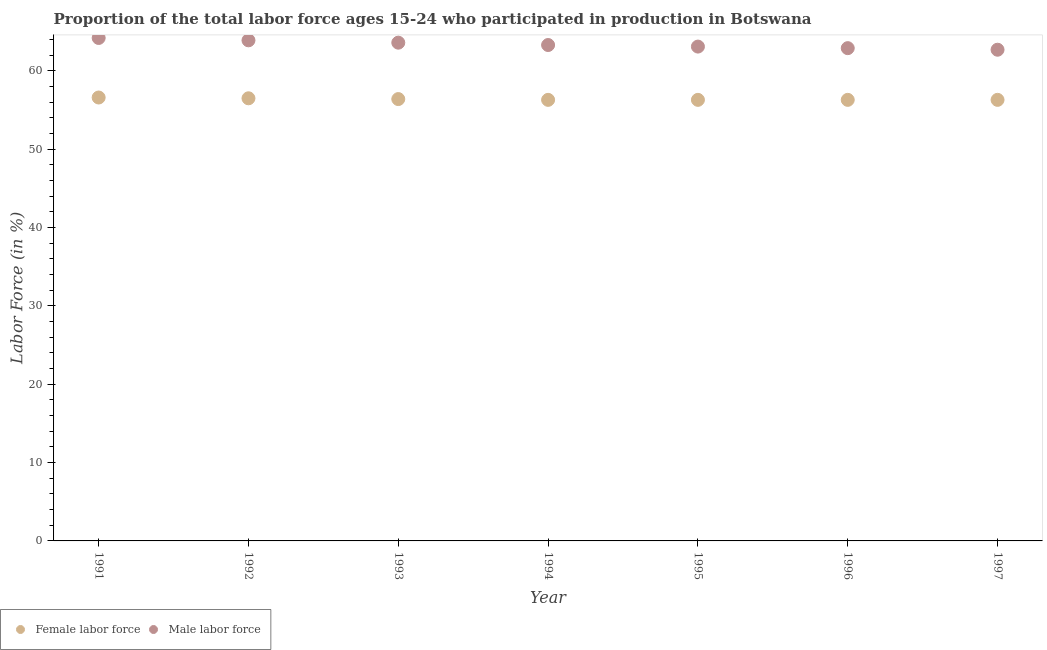How many different coloured dotlines are there?
Ensure brevity in your answer.  2. Is the number of dotlines equal to the number of legend labels?
Make the answer very short. Yes. What is the percentage of male labour force in 1995?
Give a very brief answer. 63.1. Across all years, what is the maximum percentage of female labor force?
Provide a succinct answer. 56.6. Across all years, what is the minimum percentage of male labour force?
Your answer should be very brief. 62.7. In which year was the percentage of male labour force minimum?
Ensure brevity in your answer.  1997. What is the total percentage of male labour force in the graph?
Your answer should be very brief. 443.7. What is the difference between the percentage of female labor force in 1991 and that in 1995?
Your answer should be compact. 0.3. What is the difference between the percentage of female labor force in 1993 and the percentage of male labour force in 1995?
Your response must be concise. -6.7. What is the average percentage of female labor force per year?
Make the answer very short. 56.39. In the year 1992, what is the difference between the percentage of male labour force and percentage of female labor force?
Ensure brevity in your answer.  7.4. What is the ratio of the percentage of male labour force in 1993 to that in 1996?
Your response must be concise. 1.01. Is the percentage of male labour force in 1994 less than that in 1995?
Make the answer very short. No. Is the difference between the percentage of male labour force in 1994 and 1995 greater than the difference between the percentage of female labor force in 1994 and 1995?
Make the answer very short. Yes. What is the difference between the highest and the second highest percentage of female labor force?
Your answer should be very brief. 0.1. What is the difference between the highest and the lowest percentage of female labor force?
Your response must be concise. 0.3. How many dotlines are there?
Ensure brevity in your answer.  2. How many years are there in the graph?
Provide a succinct answer. 7. Are the values on the major ticks of Y-axis written in scientific E-notation?
Provide a short and direct response. No. Does the graph contain grids?
Your response must be concise. No. What is the title of the graph?
Provide a short and direct response. Proportion of the total labor force ages 15-24 who participated in production in Botswana. What is the label or title of the X-axis?
Make the answer very short. Year. What is the label or title of the Y-axis?
Give a very brief answer. Labor Force (in %). What is the Labor Force (in %) of Female labor force in 1991?
Offer a very short reply. 56.6. What is the Labor Force (in %) in Male labor force in 1991?
Give a very brief answer. 64.2. What is the Labor Force (in %) of Female labor force in 1992?
Keep it short and to the point. 56.5. What is the Labor Force (in %) in Male labor force in 1992?
Your answer should be very brief. 63.9. What is the Labor Force (in %) in Female labor force in 1993?
Offer a very short reply. 56.4. What is the Labor Force (in %) in Male labor force in 1993?
Provide a succinct answer. 63.6. What is the Labor Force (in %) of Female labor force in 1994?
Your answer should be very brief. 56.3. What is the Labor Force (in %) of Male labor force in 1994?
Offer a very short reply. 63.3. What is the Labor Force (in %) of Female labor force in 1995?
Make the answer very short. 56.3. What is the Labor Force (in %) in Male labor force in 1995?
Provide a succinct answer. 63.1. What is the Labor Force (in %) in Female labor force in 1996?
Provide a succinct answer. 56.3. What is the Labor Force (in %) of Male labor force in 1996?
Keep it short and to the point. 62.9. What is the Labor Force (in %) of Female labor force in 1997?
Your answer should be very brief. 56.3. What is the Labor Force (in %) in Male labor force in 1997?
Offer a very short reply. 62.7. Across all years, what is the maximum Labor Force (in %) in Female labor force?
Offer a very short reply. 56.6. Across all years, what is the maximum Labor Force (in %) of Male labor force?
Your response must be concise. 64.2. Across all years, what is the minimum Labor Force (in %) in Female labor force?
Keep it short and to the point. 56.3. Across all years, what is the minimum Labor Force (in %) in Male labor force?
Provide a short and direct response. 62.7. What is the total Labor Force (in %) in Female labor force in the graph?
Your answer should be compact. 394.7. What is the total Labor Force (in %) in Male labor force in the graph?
Keep it short and to the point. 443.7. What is the difference between the Labor Force (in %) of Male labor force in 1991 and that in 1992?
Provide a short and direct response. 0.3. What is the difference between the Labor Force (in %) in Male labor force in 1991 and that in 1994?
Provide a short and direct response. 0.9. What is the difference between the Labor Force (in %) of Female labor force in 1991 and that in 1995?
Offer a terse response. 0.3. What is the difference between the Labor Force (in %) in Female labor force in 1991 and that in 1996?
Offer a terse response. 0.3. What is the difference between the Labor Force (in %) in Female labor force in 1991 and that in 1997?
Make the answer very short. 0.3. What is the difference between the Labor Force (in %) of Female labor force in 1992 and that in 1993?
Offer a very short reply. 0.1. What is the difference between the Labor Force (in %) of Male labor force in 1992 and that in 1994?
Provide a short and direct response. 0.6. What is the difference between the Labor Force (in %) of Female labor force in 1992 and that in 1995?
Your answer should be compact. 0.2. What is the difference between the Labor Force (in %) of Male labor force in 1992 and that in 1996?
Provide a short and direct response. 1. What is the difference between the Labor Force (in %) of Male labor force in 1992 and that in 1997?
Your answer should be very brief. 1.2. What is the difference between the Labor Force (in %) in Female labor force in 1993 and that in 1995?
Your response must be concise. 0.1. What is the difference between the Labor Force (in %) in Male labor force in 1993 and that in 1995?
Your answer should be very brief. 0.5. What is the difference between the Labor Force (in %) of Female labor force in 1994 and that in 1995?
Offer a very short reply. 0. What is the difference between the Labor Force (in %) of Male labor force in 1994 and that in 1995?
Offer a terse response. 0.2. What is the difference between the Labor Force (in %) in Female labor force in 1994 and that in 1996?
Offer a terse response. 0. What is the difference between the Labor Force (in %) of Male labor force in 1994 and that in 1996?
Your answer should be compact. 0.4. What is the difference between the Labor Force (in %) of Male labor force in 1994 and that in 1997?
Make the answer very short. 0.6. What is the difference between the Labor Force (in %) of Female labor force in 1995 and that in 1996?
Ensure brevity in your answer.  0. What is the difference between the Labor Force (in %) in Male labor force in 1995 and that in 1996?
Your answer should be compact. 0.2. What is the difference between the Labor Force (in %) in Male labor force in 1996 and that in 1997?
Provide a short and direct response. 0.2. What is the difference between the Labor Force (in %) in Female labor force in 1991 and the Labor Force (in %) in Male labor force in 1992?
Ensure brevity in your answer.  -7.3. What is the difference between the Labor Force (in %) in Female labor force in 1991 and the Labor Force (in %) in Male labor force in 1993?
Give a very brief answer. -7. What is the difference between the Labor Force (in %) of Female labor force in 1991 and the Labor Force (in %) of Male labor force in 1994?
Provide a succinct answer. -6.7. What is the difference between the Labor Force (in %) in Female labor force in 1991 and the Labor Force (in %) in Male labor force in 1997?
Provide a succinct answer. -6.1. What is the difference between the Labor Force (in %) in Female labor force in 1992 and the Labor Force (in %) in Male labor force in 1993?
Provide a succinct answer. -7.1. What is the difference between the Labor Force (in %) in Female labor force in 1992 and the Labor Force (in %) in Male labor force in 1996?
Provide a succinct answer. -6.4. What is the difference between the Labor Force (in %) in Female labor force in 1992 and the Labor Force (in %) in Male labor force in 1997?
Offer a terse response. -6.2. What is the difference between the Labor Force (in %) of Female labor force in 1994 and the Labor Force (in %) of Male labor force in 1995?
Offer a very short reply. -6.8. What is the difference between the Labor Force (in %) of Female labor force in 1994 and the Labor Force (in %) of Male labor force in 1996?
Your answer should be compact. -6.6. What is the difference between the Labor Force (in %) in Female labor force in 1996 and the Labor Force (in %) in Male labor force in 1997?
Provide a short and direct response. -6.4. What is the average Labor Force (in %) of Female labor force per year?
Ensure brevity in your answer.  56.39. What is the average Labor Force (in %) in Male labor force per year?
Your answer should be compact. 63.39. In the year 1994, what is the difference between the Labor Force (in %) in Female labor force and Labor Force (in %) in Male labor force?
Provide a succinct answer. -7. What is the ratio of the Labor Force (in %) of Female labor force in 1991 to that in 1993?
Your answer should be very brief. 1. What is the ratio of the Labor Force (in %) of Male labor force in 1991 to that in 1993?
Ensure brevity in your answer.  1.01. What is the ratio of the Labor Force (in %) in Male labor force in 1991 to that in 1994?
Make the answer very short. 1.01. What is the ratio of the Labor Force (in %) of Male labor force in 1991 to that in 1995?
Your answer should be compact. 1.02. What is the ratio of the Labor Force (in %) in Male labor force in 1991 to that in 1996?
Offer a very short reply. 1.02. What is the ratio of the Labor Force (in %) in Female labor force in 1991 to that in 1997?
Keep it short and to the point. 1.01. What is the ratio of the Labor Force (in %) in Male labor force in 1991 to that in 1997?
Provide a succinct answer. 1.02. What is the ratio of the Labor Force (in %) of Female labor force in 1992 to that in 1993?
Give a very brief answer. 1. What is the ratio of the Labor Force (in %) in Female labor force in 1992 to that in 1994?
Ensure brevity in your answer.  1. What is the ratio of the Labor Force (in %) in Male labor force in 1992 to that in 1994?
Offer a terse response. 1.01. What is the ratio of the Labor Force (in %) of Female labor force in 1992 to that in 1995?
Ensure brevity in your answer.  1. What is the ratio of the Labor Force (in %) in Male labor force in 1992 to that in 1995?
Offer a terse response. 1.01. What is the ratio of the Labor Force (in %) of Female labor force in 1992 to that in 1996?
Provide a succinct answer. 1. What is the ratio of the Labor Force (in %) of Male labor force in 1992 to that in 1996?
Make the answer very short. 1.02. What is the ratio of the Labor Force (in %) of Female labor force in 1992 to that in 1997?
Your answer should be compact. 1. What is the ratio of the Labor Force (in %) of Male labor force in 1992 to that in 1997?
Ensure brevity in your answer.  1.02. What is the ratio of the Labor Force (in %) in Female labor force in 1993 to that in 1994?
Your response must be concise. 1. What is the ratio of the Labor Force (in %) of Female labor force in 1993 to that in 1995?
Make the answer very short. 1. What is the ratio of the Labor Force (in %) of Male labor force in 1993 to that in 1995?
Give a very brief answer. 1.01. What is the ratio of the Labor Force (in %) of Female labor force in 1993 to that in 1996?
Give a very brief answer. 1. What is the ratio of the Labor Force (in %) of Male labor force in 1993 to that in 1996?
Offer a terse response. 1.01. What is the ratio of the Labor Force (in %) in Male labor force in 1993 to that in 1997?
Give a very brief answer. 1.01. What is the ratio of the Labor Force (in %) of Male labor force in 1994 to that in 1996?
Give a very brief answer. 1.01. What is the ratio of the Labor Force (in %) of Female labor force in 1994 to that in 1997?
Offer a terse response. 1. What is the ratio of the Labor Force (in %) in Male labor force in 1994 to that in 1997?
Offer a terse response. 1.01. What is the ratio of the Labor Force (in %) of Female labor force in 1995 to that in 1996?
Your response must be concise. 1. What is the ratio of the Labor Force (in %) of Male labor force in 1995 to that in 1996?
Ensure brevity in your answer.  1. What is the ratio of the Labor Force (in %) in Male labor force in 1995 to that in 1997?
Your response must be concise. 1.01. What is the ratio of the Labor Force (in %) in Female labor force in 1996 to that in 1997?
Your response must be concise. 1. What is the difference between the highest and the second highest Labor Force (in %) in Female labor force?
Keep it short and to the point. 0.1. What is the difference between the highest and the lowest Labor Force (in %) of Female labor force?
Make the answer very short. 0.3. What is the difference between the highest and the lowest Labor Force (in %) in Male labor force?
Keep it short and to the point. 1.5. 